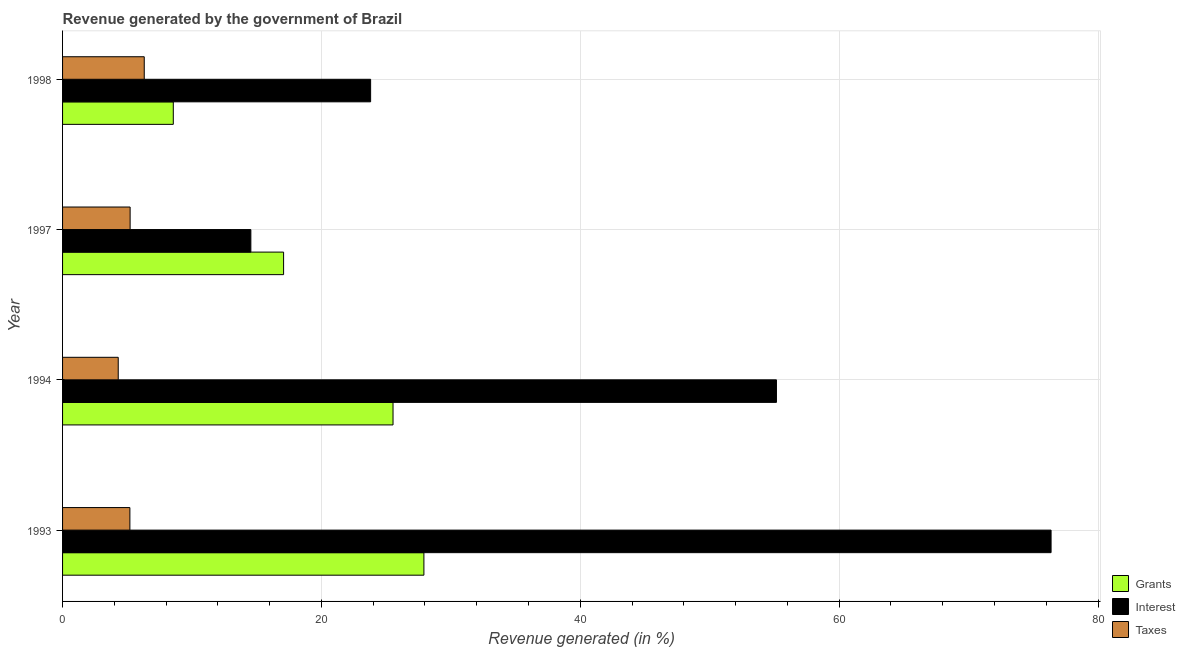How many groups of bars are there?
Make the answer very short. 4. Are the number of bars on each tick of the Y-axis equal?
Ensure brevity in your answer.  Yes. How many bars are there on the 3rd tick from the top?
Offer a very short reply. 3. How many bars are there on the 3rd tick from the bottom?
Offer a terse response. 3. What is the percentage of revenue generated by interest in 1998?
Your answer should be very brief. 23.8. Across all years, what is the maximum percentage of revenue generated by grants?
Provide a short and direct response. 27.92. Across all years, what is the minimum percentage of revenue generated by grants?
Offer a very short reply. 8.56. In which year was the percentage of revenue generated by taxes maximum?
Ensure brevity in your answer.  1998. In which year was the percentage of revenue generated by taxes minimum?
Your answer should be very brief. 1994. What is the total percentage of revenue generated by grants in the graph?
Your answer should be very brief. 79.08. What is the difference between the percentage of revenue generated by grants in 1994 and that in 1998?
Your response must be concise. 16.98. What is the difference between the percentage of revenue generated by grants in 1994 and the percentage of revenue generated by interest in 1993?
Your answer should be very brief. -50.84. What is the average percentage of revenue generated by taxes per year?
Make the answer very short. 5.26. In the year 1993, what is the difference between the percentage of revenue generated by taxes and percentage of revenue generated by interest?
Ensure brevity in your answer.  -71.17. What is the ratio of the percentage of revenue generated by interest in 1994 to that in 1998?
Your answer should be very brief. 2.32. Is the difference between the percentage of revenue generated by taxes in 1994 and 1998 greater than the difference between the percentage of revenue generated by interest in 1994 and 1998?
Provide a succinct answer. No. What is the difference between the highest and the second highest percentage of revenue generated by grants?
Offer a very short reply. 2.38. What is the difference between the highest and the lowest percentage of revenue generated by interest?
Give a very brief answer. 61.83. In how many years, is the percentage of revenue generated by grants greater than the average percentage of revenue generated by grants taken over all years?
Your answer should be very brief. 2. What does the 3rd bar from the top in 1998 represents?
Provide a short and direct response. Grants. What does the 1st bar from the bottom in 1998 represents?
Make the answer very short. Grants. How many bars are there?
Provide a succinct answer. 12. How many years are there in the graph?
Offer a very short reply. 4. Are the values on the major ticks of X-axis written in scientific E-notation?
Keep it short and to the point. No. Does the graph contain any zero values?
Provide a succinct answer. No. Does the graph contain grids?
Provide a succinct answer. Yes. How are the legend labels stacked?
Ensure brevity in your answer.  Vertical. What is the title of the graph?
Offer a terse response. Revenue generated by the government of Brazil. What is the label or title of the X-axis?
Provide a short and direct response. Revenue generated (in %). What is the label or title of the Y-axis?
Your answer should be compact. Year. What is the Revenue generated (in %) of Grants in 1993?
Offer a terse response. 27.92. What is the Revenue generated (in %) of Interest in 1993?
Your answer should be compact. 76.37. What is the Revenue generated (in %) in Taxes in 1993?
Provide a short and direct response. 5.2. What is the Revenue generated (in %) of Grants in 1994?
Ensure brevity in your answer.  25.53. What is the Revenue generated (in %) in Interest in 1994?
Give a very brief answer. 55.16. What is the Revenue generated (in %) of Taxes in 1994?
Offer a terse response. 4.3. What is the Revenue generated (in %) of Grants in 1997?
Your answer should be compact. 17.08. What is the Revenue generated (in %) of Interest in 1997?
Your response must be concise. 14.55. What is the Revenue generated (in %) in Taxes in 1997?
Give a very brief answer. 5.22. What is the Revenue generated (in %) in Grants in 1998?
Offer a terse response. 8.56. What is the Revenue generated (in %) of Interest in 1998?
Make the answer very short. 23.8. What is the Revenue generated (in %) in Taxes in 1998?
Offer a terse response. 6.31. Across all years, what is the maximum Revenue generated (in %) in Grants?
Provide a succinct answer. 27.92. Across all years, what is the maximum Revenue generated (in %) of Interest?
Provide a succinct answer. 76.37. Across all years, what is the maximum Revenue generated (in %) in Taxes?
Make the answer very short. 6.31. Across all years, what is the minimum Revenue generated (in %) in Grants?
Offer a very short reply. 8.56. Across all years, what is the minimum Revenue generated (in %) of Interest?
Offer a very short reply. 14.55. Across all years, what is the minimum Revenue generated (in %) of Taxes?
Make the answer very short. 4.3. What is the total Revenue generated (in %) in Grants in the graph?
Keep it short and to the point. 79.08. What is the total Revenue generated (in %) in Interest in the graph?
Offer a terse response. 169.88. What is the total Revenue generated (in %) of Taxes in the graph?
Offer a terse response. 21.03. What is the difference between the Revenue generated (in %) in Grants in 1993 and that in 1994?
Offer a terse response. 2.39. What is the difference between the Revenue generated (in %) of Interest in 1993 and that in 1994?
Give a very brief answer. 21.22. What is the difference between the Revenue generated (in %) of Taxes in 1993 and that in 1994?
Give a very brief answer. 0.9. What is the difference between the Revenue generated (in %) of Grants in 1993 and that in 1997?
Offer a very short reply. 10.84. What is the difference between the Revenue generated (in %) in Interest in 1993 and that in 1997?
Offer a very short reply. 61.83. What is the difference between the Revenue generated (in %) in Taxes in 1993 and that in 1997?
Ensure brevity in your answer.  -0.02. What is the difference between the Revenue generated (in %) of Grants in 1993 and that in 1998?
Make the answer very short. 19.36. What is the difference between the Revenue generated (in %) in Interest in 1993 and that in 1998?
Make the answer very short. 52.57. What is the difference between the Revenue generated (in %) of Taxes in 1993 and that in 1998?
Ensure brevity in your answer.  -1.11. What is the difference between the Revenue generated (in %) in Grants in 1994 and that in 1997?
Ensure brevity in your answer.  8.46. What is the difference between the Revenue generated (in %) in Interest in 1994 and that in 1997?
Offer a terse response. 40.61. What is the difference between the Revenue generated (in %) in Taxes in 1994 and that in 1997?
Offer a very short reply. -0.92. What is the difference between the Revenue generated (in %) of Grants in 1994 and that in 1998?
Give a very brief answer. 16.98. What is the difference between the Revenue generated (in %) of Interest in 1994 and that in 1998?
Give a very brief answer. 31.35. What is the difference between the Revenue generated (in %) in Taxes in 1994 and that in 1998?
Keep it short and to the point. -2.01. What is the difference between the Revenue generated (in %) of Grants in 1997 and that in 1998?
Your answer should be very brief. 8.52. What is the difference between the Revenue generated (in %) in Interest in 1997 and that in 1998?
Ensure brevity in your answer.  -9.25. What is the difference between the Revenue generated (in %) in Taxes in 1997 and that in 1998?
Ensure brevity in your answer.  -1.09. What is the difference between the Revenue generated (in %) of Grants in 1993 and the Revenue generated (in %) of Interest in 1994?
Offer a very short reply. -27.24. What is the difference between the Revenue generated (in %) in Grants in 1993 and the Revenue generated (in %) in Taxes in 1994?
Offer a terse response. 23.62. What is the difference between the Revenue generated (in %) in Interest in 1993 and the Revenue generated (in %) in Taxes in 1994?
Your answer should be very brief. 72.07. What is the difference between the Revenue generated (in %) in Grants in 1993 and the Revenue generated (in %) in Interest in 1997?
Your answer should be very brief. 13.37. What is the difference between the Revenue generated (in %) of Grants in 1993 and the Revenue generated (in %) of Taxes in 1997?
Provide a short and direct response. 22.7. What is the difference between the Revenue generated (in %) in Interest in 1993 and the Revenue generated (in %) in Taxes in 1997?
Make the answer very short. 71.15. What is the difference between the Revenue generated (in %) in Grants in 1993 and the Revenue generated (in %) in Interest in 1998?
Provide a short and direct response. 4.12. What is the difference between the Revenue generated (in %) in Grants in 1993 and the Revenue generated (in %) in Taxes in 1998?
Offer a very short reply. 21.61. What is the difference between the Revenue generated (in %) of Interest in 1993 and the Revenue generated (in %) of Taxes in 1998?
Provide a succinct answer. 70.06. What is the difference between the Revenue generated (in %) of Grants in 1994 and the Revenue generated (in %) of Interest in 1997?
Ensure brevity in your answer.  10.98. What is the difference between the Revenue generated (in %) of Grants in 1994 and the Revenue generated (in %) of Taxes in 1997?
Offer a terse response. 20.31. What is the difference between the Revenue generated (in %) in Interest in 1994 and the Revenue generated (in %) in Taxes in 1997?
Your answer should be very brief. 49.94. What is the difference between the Revenue generated (in %) in Grants in 1994 and the Revenue generated (in %) in Interest in 1998?
Offer a very short reply. 1.73. What is the difference between the Revenue generated (in %) in Grants in 1994 and the Revenue generated (in %) in Taxes in 1998?
Your answer should be very brief. 19.22. What is the difference between the Revenue generated (in %) of Interest in 1994 and the Revenue generated (in %) of Taxes in 1998?
Your answer should be very brief. 48.84. What is the difference between the Revenue generated (in %) of Grants in 1997 and the Revenue generated (in %) of Interest in 1998?
Provide a short and direct response. -6.72. What is the difference between the Revenue generated (in %) in Grants in 1997 and the Revenue generated (in %) in Taxes in 1998?
Make the answer very short. 10.77. What is the difference between the Revenue generated (in %) in Interest in 1997 and the Revenue generated (in %) in Taxes in 1998?
Keep it short and to the point. 8.24. What is the average Revenue generated (in %) of Grants per year?
Give a very brief answer. 19.77. What is the average Revenue generated (in %) of Interest per year?
Ensure brevity in your answer.  42.47. What is the average Revenue generated (in %) of Taxes per year?
Offer a very short reply. 5.26. In the year 1993, what is the difference between the Revenue generated (in %) in Grants and Revenue generated (in %) in Interest?
Offer a terse response. -48.46. In the year 1993, what is the difference between the Revenue generated (in %) in Grants and Revenue generated (in %) in Taxes?
Provide a succinct answer. 22.72. In the year 1993, what is the difference between the Revenue generated (in %) of Interest and Revenue generated (in %) of Taxes?
Your response must be concise. 71.17. In the year 1994, what is the difference between the Revenue generated (in %) in Grants and Revenue generated (in %) in Interest?
Give a very brief answer. -29.62. In the year 1994, what is the difference between the Revenue generated (in %) of Grants and Revenue generated (in %) of Taxes?
Keep it short and to the point. 21.23. In the year 1994, what is the difference between the Revenue generated (in %) of Interest and Revenue generated (in %) of Taxes?
Your response must be concise. 50.85. In the year 1997, what is the difference between the Revenue generated (in %) of Grants and Revenue generated (in %) of Interest?
Provide a short and direct response. 2.53. In the year 1997, what is the difference between the Revenue generated (in %) in Grants and Revenue generated (in %) in Taxes?
Keep it short and to the point. 11.86. In the year 1997, what is the difference between the Revenue generated (in %) in Interest and Revenue generated (in %) in Taxes?
Your answer should be very brief. 9.33. In the year 1998, what is the difference between the Revenue generated (in %) in Grants and Revenue generated (in %) in Interest?
Keep it short and to the point. -15.25. In the year 1998, what is the difference between the Revenue generated (in %) of Grants and Revenue generated (in %) of Taxes?
Your answer should be very brief. 2.24. In the year 1998, what is the difference between the Revenue generated (in %) in Interest and Revenue generated (in %) in Taxes?
Give a very brief answer. 17.49. What is the ratio of the Revenue generated (in %) of Grants in 1993 to that in 1994?
Keep it short and to the point. 1.09. What is the ratio of the Revenue generated (in %) in Interest in 1993 to that in 1994?
Give a very brief answer. 1.38. What is the ratio of the Revenue generated (in %) of Taxes in 1993 to that in 1994?
Keep it short and to the point. 1.21. What is the ratio of the Revenue generated (in %) of Grants in 1993 to that in 1997?
Provide a succinct answer. 1.63. What is the ratio of the Revenue generated (in %) of Interest in 1993 to that in 1997?
Provide a short and direct response. 5.25. What is the ratio of the Revenue generated (in %) in Taxes in 1993 to that in 1997?
Give a very brief answer. 1. What is the ratio of the Revenue generated (in %) of Grants in 1993 to that in 1998?
Make the answer very short. 3.26. What is the ratio of the Revenue generated (in %) of Interest in 1993 to that in 1998?
Ensure brevity in your answer.  3.21. What is the ratio of the Revenue generated (in %) of Taxes in 1993 to that in 1998?
Provide a short and direct response. 0.82. What is the ratio of the Revenue generated (in %) in Grants in 1994 to that in 1997?
Offer a very short reply. 1.5. What is the ratio of the Revenue generated (in %) of Interest in 1994 to that in 1997?
Offer a terse response. 3.79. What is the ratio of the Revenue generated (in %) in Taxes in 1994 to that in 1997?
Your answer should be very brief. 0.82. What is the ratio of the Revenue generated (in %) in Grants in 1994 to that in 1998?
Ensure brevity in your answer.  2.98. What is the ratio of the Revenue generated (in %) of Interest in 1994 to that in 1998?
Your answer should be very brief. 2.32. What is the ratio of the Revenue generated (in %) of Taxes in 1994 to that in 1998?
Make the answer very short. 0.68. What is the ratio of the Revenue generated (in %) in Grants in 1997 to that in 1998?
Give a very brief answer. 2. What is the ratio of the Revenue generated (in %) in Interest in 1997 to that in 1998?
Make the answer very short. 0.61. What is the ratio of the Revenue generated (in %) of Taxes in 1997 to that in 1998?
Offer a very short reply. 0.83. What is the difference between the highest and the second highest Revenue generated (in %) of Grants?
Offer a very short reply. 2.39. What is the difference between the highest and the second highest Revenue generated (in %) of Interest?
Provide a short and direct response. 21.22. What is the difference between the highest and the second highest Revenue generated (in %) of Taxes?
Offer a terse response. 1.09. What is the difference between the highest and the lowest Revenue generated (in %) of Grants?
Your answer should be compact. 19.36. What is the difference between the highest and the lowest Revenue generated (in %) of Interest?
Make the answer very short. 61.83. What is the difference between the highest and the lowest Revenue generated (in %) in Taxes?
Provide a succinct answer. 2.01. 